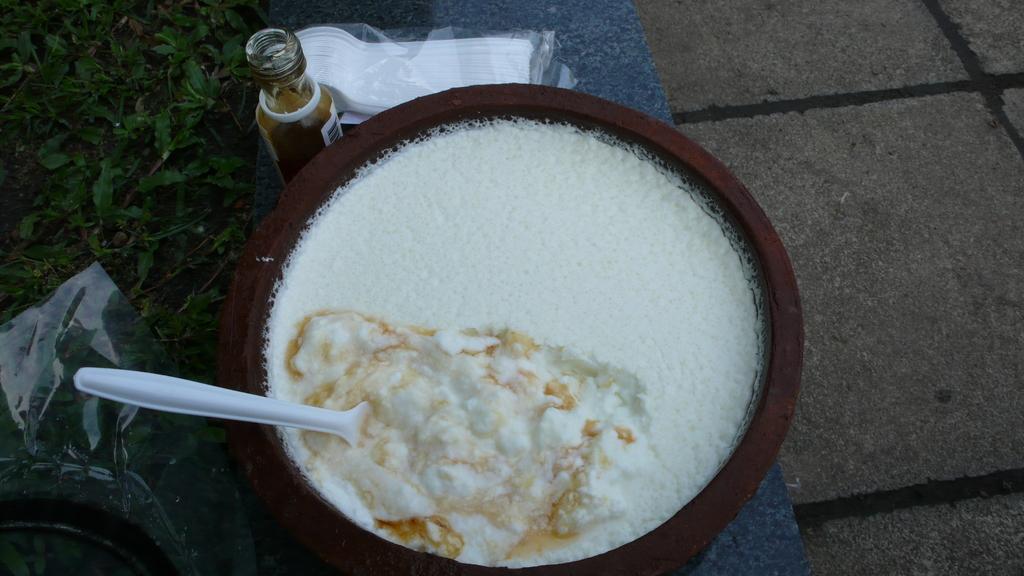Describe this image in one or two sentences. This image consist of food which is in the center. On the left side there's grass on the ground. On the top there is a bottle and there is a packet with white colour object inside it. 